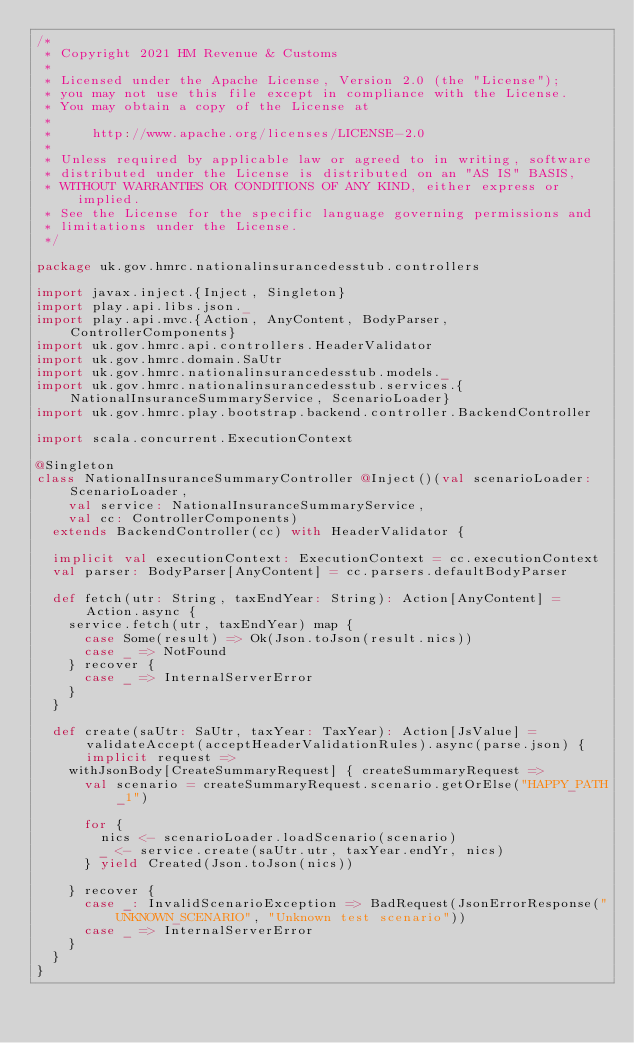Convert code to text. <code><loc_0><loc_0><loc_500><loc_500><_Scala_>/*
 * Copyright 2021 HM Revenue & Customs
 *
 * Licensed under the Apache License, Version 2.0 (the "License");
 * you may not use this file except in compliance with the License.
 * You may obtain a copy of the License at
 *
 *     http://www.apache.org/licenses/LICENSE-2.0
 *
 * Unless required by applicable law or agreed to in writing, software
 * distributed under the License is distributed on an "AS IS" BASIS,
 * WITHOUT WARRANTIES OR CONDITIONS OF ANY KIND, either express or implied.
 * See the License for the specific language governing permissions and
 * limitations under the License.
 */

package uk.gov.hmrc.nationalinsurancedesstub.controllers

import javax.inject.{Inject, Singleton}
import play.api.libs.json._
import play.api.mvc.{Action, AnyContent, BodyParser, ControllerComponents}
import uk.gov.hmrc.api.controllers.HeaderValidator
import uk.gov.hmrc.domain.SaUtr
import uk.gov.hmrc.nationalinsurancedesstub.models._
import uk.gov.hmrc.nationalinsurancedesstub.services.{NationalInsuranceSummaryService, ScenarioLoader}
import uk.gov.hmrc.play.bootstrap.backend.controller.BackendController

import scala.concurrent.ExecutionContext

@Singleton
class NationalInsuranceSummaryController @Inject()(val scenarioLoader: ScenarioLoader,
    val service: NationalInsuranceSummaryService,
    val cc: ControllerComponents)
  extends BackendController(cc) with HeaderValidator {

  implicit val executionContext: ExecutionContext = cc.executionContext
  val parser: BodyParser[AnyContent] = cc.parsers.defaultBodyParser

  def fetch(utr: String, taxEndYear: String): Action[AnyContent] = Action.async {
    service.fetch(utr, taxEndYear) map {
      case Some(result) => Ok(Json.toJson(result.nics))
      case _ => NotFound
    } recover {
      case _ => InternalServerError
    }
  }

  def create(saUtr: SaUtr, taxYear: TaxYear): Action[JsValue] = validateAccept(acceptHeaderValidationRules).async(parse.json) { implicit request =>
    withJsonBody[CreateSummaryRequest] { createSummaryRequest =>
      val scenario = createSummaryRequest.scenario.getOrElse("HAPPY_PATH_1")

      for {
        nics <- scenarioLoader.loadScenario(scenario)
        _ <- service.create(saUtr.utr, taxYear.endYr, nics)
      } yield Created(Json.toJson(nics))

    } recover {
      case _: InvalidScenarioException => BadRequest(JsonErrorResponse("UNKNOWN_SCENARIO", "Unknown test scenario"))
      case _ => InternalServerError
    }
  }
}
</code> 